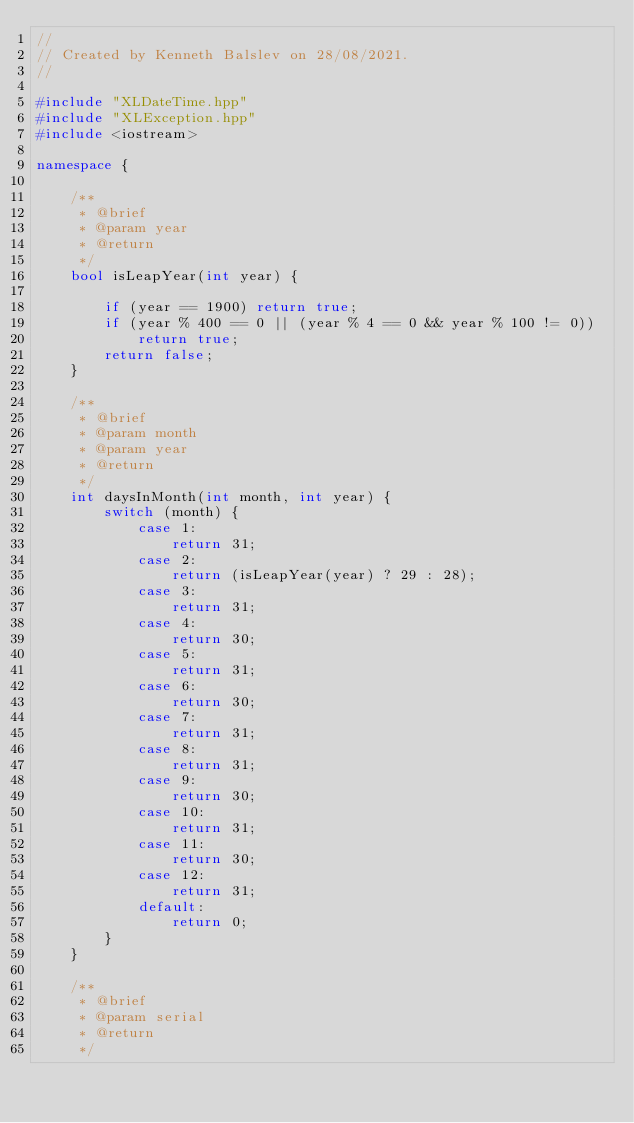Convert code to text. <code><loc_0><loc_0><loc_500><loc_500><_C++_>//
// Created by Kenneth Balslev on 28/08/2021.
//

#include "XLDateTime.hpp"
#include "XLException.hpp"
#include <iostream>

namespace {

    /**
     * @brief
     * @param year
     * @return
     */
    bool isLeapYear(int year) {

        if (year == 1900) return true;
        if (year % 400 == 0 || (year % 4 == 0 && year % 100 != 0))
            return true;
        return false;
    }

    /**
     * @brief
     * @param month
     * @param year
     * @return
     */
    int daysInMonth(int month, int year) {
        switch (month) {
            case 1:
                return 31;
            case 2:
                return (isLeapYear(year) ? 29 : 28);
            case 3:
                return 31;
            case 4:
                return 30;
            case 5:
                return 31;
            case 6:
                return 30;
            case 7:
                return 31;
            case 8:
                return 31;
            case 9:
                return 30;
            case 10:
                return 31;
            case 11:
                return 30;
            case 12:
                return 31;
            default:
                return 0;
        }
    }

    /**
     * @brief
     * @param serial
     * @return
     */</code> 